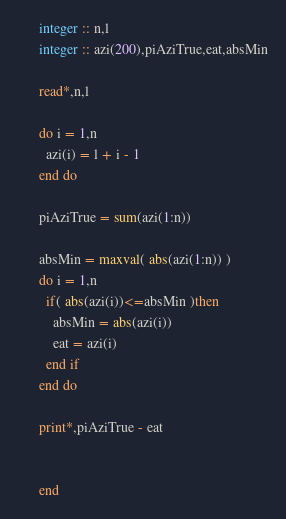<code> <loc_0><loc_0><loc_500><loc_500><_FORTRAN_>      integer :: n,l
      integer :: azi(200),piAziTrue,eat,absMin
      
      read*,n,l
      
      do i = 1,n
        azi(i) = l + i - 1
      end do
      
      piAziTrue = sum(azi(1:n))
      
      absMin = maxval( abs(azi(1:n)) )
      do i = 1,n
        if( abs(azi(i))<=absMin )then
          absMin = abs(azi(i))
          eat = azi(i)
        end if
      end do
      
      print*,piAziTrue - eat
      
      
      end
</code> 